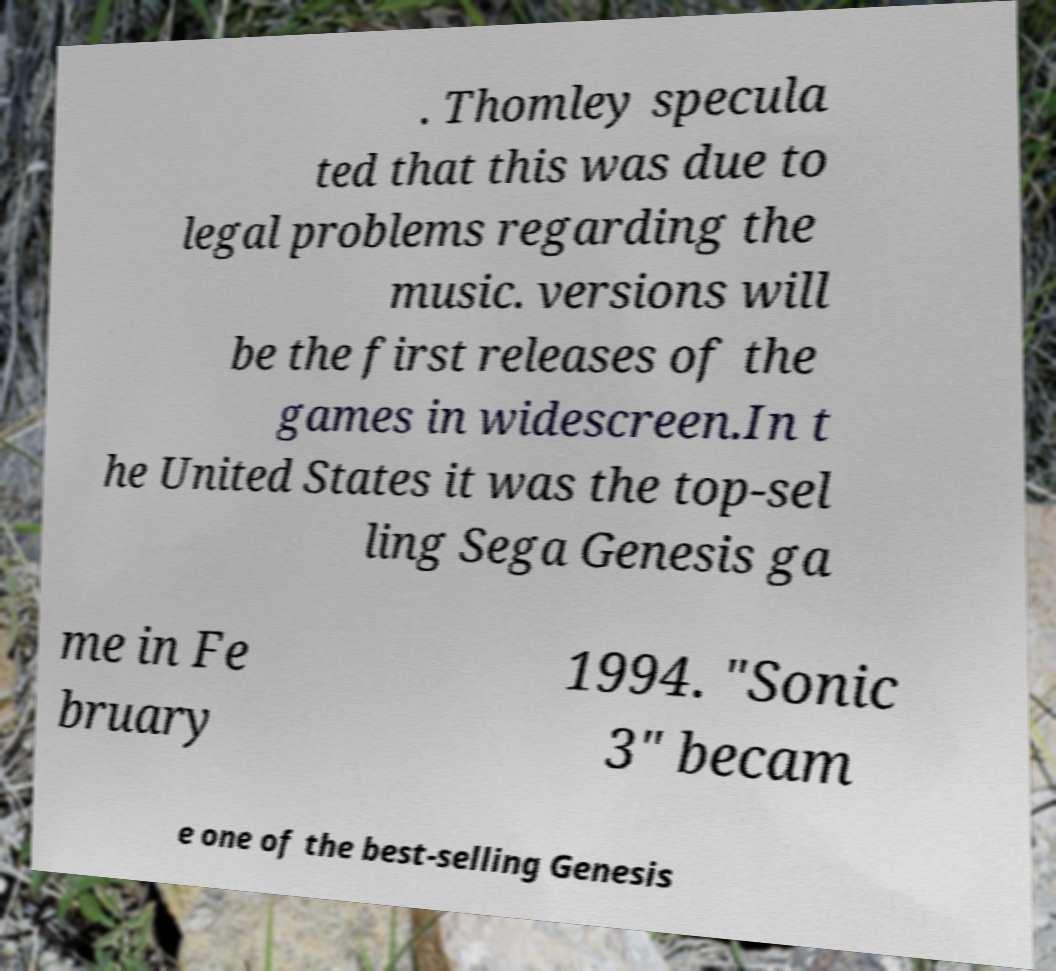There's text embedded in this image that I need extracted. Can you transcribe it verbatim? . Thomley specula ted that this was due to legal problems regarding the music. versions will be the first releases of the games in widescreen.In t he United States it was the top-sel ling Sega Genesis ga me in Fe bruary 1994. "Sonic 3" becam e one of the best-selling Genesis 